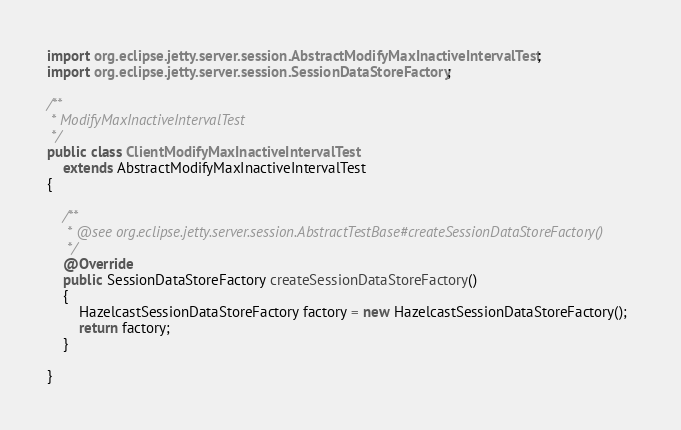<code> <loc_0><loc_0><loc_500><loc_500><_Java_>import org.eclipse.jetty.server.session.AbstractModifyMaxInactiveIntervalTest;
import org.eclipse.jetty.server.session.SessionDataStoreFactory;

/**
 * ModifyMaxInactiveIntervalTest
 */
public class ClientModifyMaxInactiveIntervalTest
    extends AbstractModifyMaxInactiveIntervalTest
{

    /**
     * @see org.eclipse.jetty.server.session.AbstractTestBase#createSessionDataStoreFactory()
     */
    @Override
    public SessionDataStoreFactory createSessionDataStoreFactory()
    {
        HazelcastSessionDataStoreFactory factory = new HazelcastSessionDataStoreFactory();
        return factory;
    }

}
</code> 